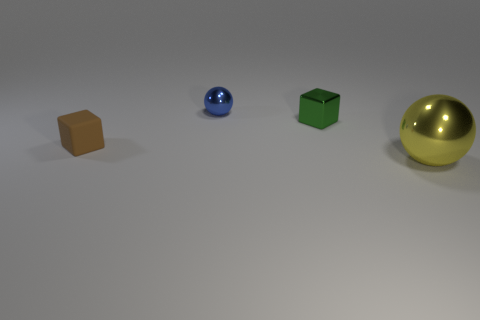Is there any other thing that has the same material as the small blue sphere?
Offer a very short reply. Yes. What is the shape of the object that is in front of the tiny brown matte block?
Your response must be concise. Sphere. Are there any brown matte objects of the same size as the green thing?
Provide a succinct answer. Yes. Does the ball that is left of the large thing have the same material as the big yellow object?
Make the answer very short. Yes. Are there an equal number of big yellow things that are right of the yellow metal thing and tiny brown cubes that are in front of the blue sphere?
Give a very brief answer. No. What is the shape of the thing that is both in front of the tiny blue metallic object and behind the tiny matte thing?
Make the answer very short. Cube. How many big yellow metallic balls are behind the big yellow shiny ball?
Your answer should be very brief. 0. What number of other objects are there of the same shape as the large shiny thing?
Offer a terse response. 1. Are there fewer purple rubber blocks than objects?
Your answer should be compact. Yes. What size is the thing that is both left of the tiny shiny cube and on the right side of the small brown thing?
Your response must be concise. Small. 